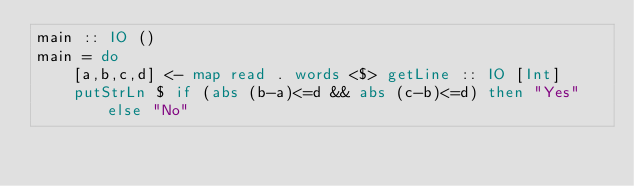<code> <loc_0><loc_0><loc_500><loc_500><_Haskell_>main :: IO ()
main = do
    [a,b,c,d] <- map read . words <$> getLine :: IO [Int]
    putStrLn $ if (abs (b-a)<=d && abs (c-b)<=d) then "Yes" else "No"</code> 